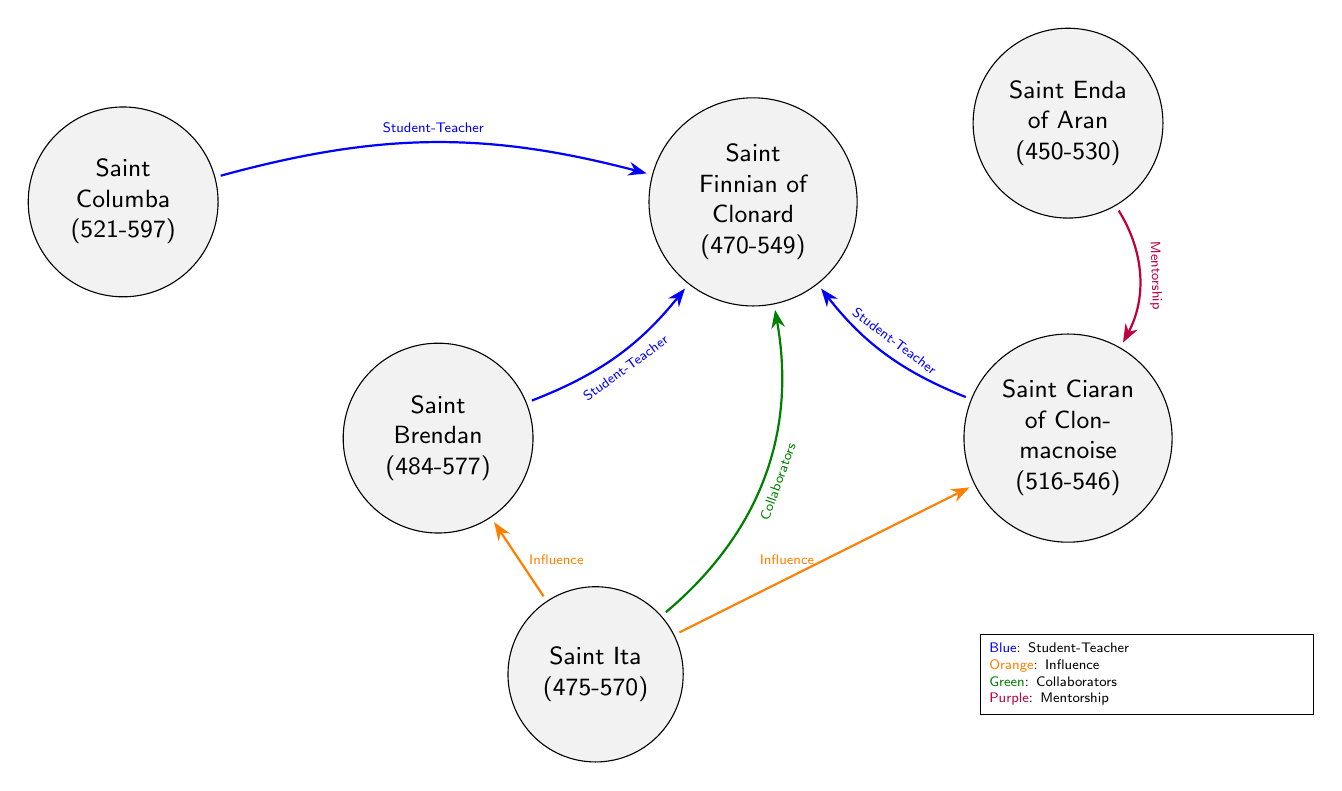What is the relationship between Saint Columba and Saint Finnian? The diagram indicates a "Student-Teacher" relationship between Saint Columba and Saint Finnian, represented with a blue arrow connecting them.
Answer: Student-Teacher How many scholars are depicted in the diagram? Counting the nodes in the diagram, we identify six scholars: Saint Columba, Saint Brendan, Saint Finnian, Saint Ciaran, Saint Ita, and Saint Enda.
Answer: 6 What type of influence does Saint Ita have on Saint Brendan? The diagram shows a relationship labeled "Influence" represented with an orange arrow connecting Saint Ita and Saint Brendan.
Answer: Influence Which scholar is a mentee of Saint Enda? The diagram shows a "Mentorship" relationship between Saint Enda and Saint Ciaran, indicating that Ciaran is a mentee of Enda.
Answer: Saint Ciaran How many types of connections are illustrated in the diagram? The connections in the diagram are categorized into four types: Student-Teacher, Influence, Collaborators, and Mentorship, as represented by different colors.
Answer: 4 Which scholar is connected as a collaborator with Saint Finnian? The visualization indicates that Saint Ita is connected to Saint Finnian with a relationship labeled "Collaborators," shown with a green arrow.
Answer: Saint Ita Who are the students of Saint Finnian? The diagram illustrates that three scholars (Saint Columba, Saint Brendan, and Saint Ciaran) are connected to Saint Finnian with a "Student-Teacher" relationship.
Answer: Saint Columba, Saint Brendan, Saint Ciaran 